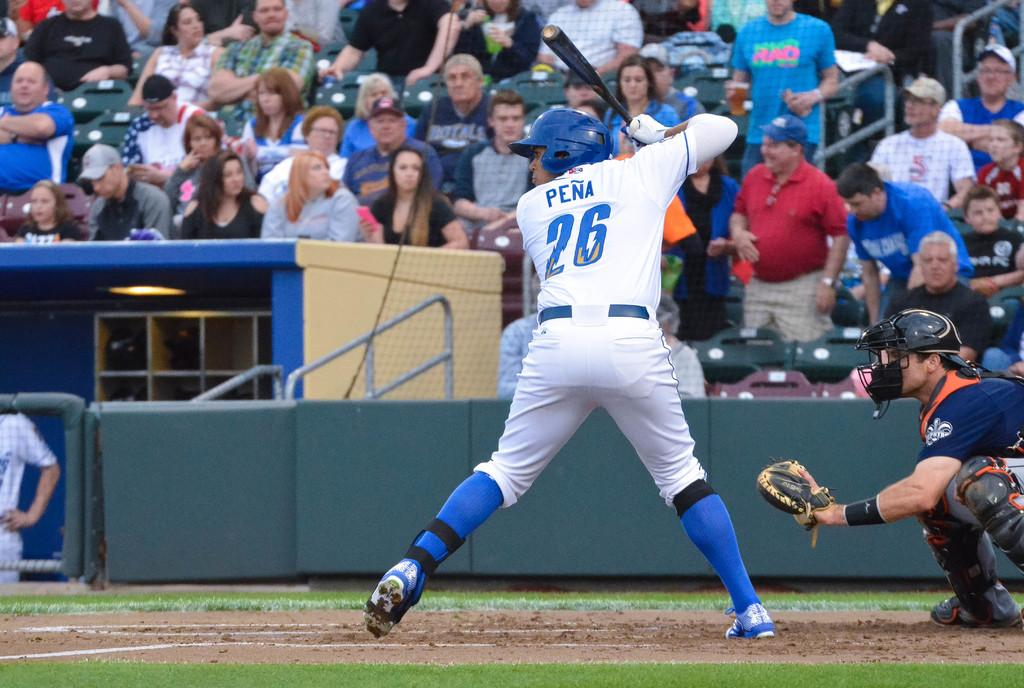<image>
Relay a brief, clear account of the picture shown. A baseball player up to bat with the name Pena and the number 26. 